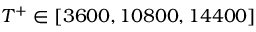Convert formula to latex. <formula><loc_0><loc_0><loc_500><loc_500>T ^ { + } \in [ 3 6 0 0 , 1 0 8 0 0 , 1 4 4 0 0 ]</formula> 